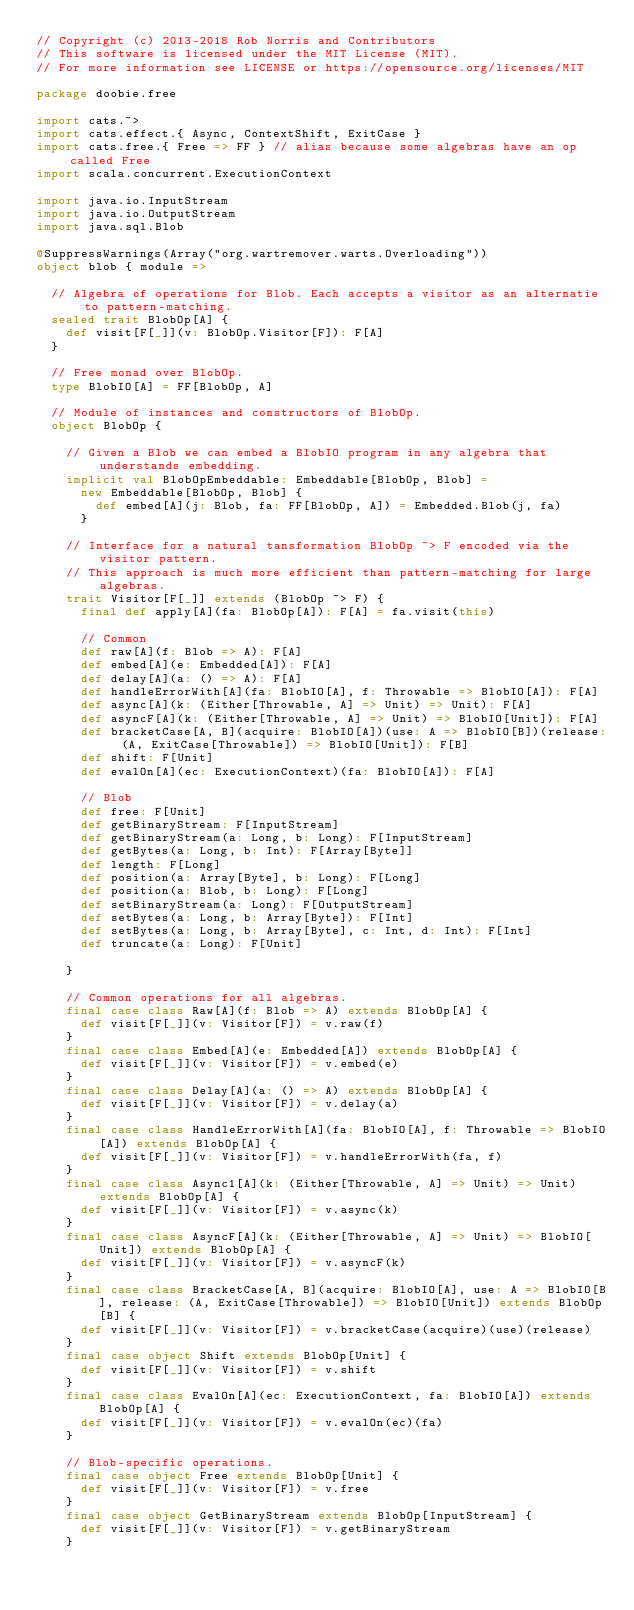<code> <loc_0><loc_0><loc_500><loc_500><_Scala_>// Copyright (c) 2013-2018 Rob Norris and Contributors
// This software is licensed under the MIT License (MIT).
// For more information see LICENSE or https://opensource.org/licenses/MIT

package doobie.free

import cats.~>
import cats.effect.{ Async, ContextShift, ExitCase }
import cats.free.{ Free => FF } // alias because some algebras have an op called Free
import scala.concurrent.ExecutionContext

import java.io.InputStream
import java.io.OutputStream
import java.sql.Blob

@SuppressWarnings(Array("org.wartremover.warts.Overloading"))
object blob { module =>

  // Algebra of operations for Blob. Each accepts a visitor as an alternatie to pattern-matching.
  sealed trait BlobOp[A] {
    def visit[F[_]](v: BlobOp.Visitor[F]): F[A]
  }

  // Free monad over BlobOp.
  type BlobIO[A] = FF[BlobOp, A]

  // Module of instances and constructors of BlobOp.
  object BlobOp {

    // Given a Blob we can embed a BlobIO program in any algebra that understands embedding.
    implicit val BlobOpEmbeddable: Embeddable[BlobOp, Blob] =
      new Embeddable[BlobOp, Blob] {
        def embed[A](j: Blob, fa: FF[BlobOp, A]) = Embedded.Blob(j, fa)
      }

    // Interface for a natural tansformation BlobOp ~> F encoded via the visitor pattern.
    // This approach is much more efficient than pattern-matching for large algebras.
    trait Visitor[F[_]] extends (BlobOp ~> F) {
      final def apply[A](fa: BlobOp[A]): F[A] = fa.visit(this)

      // Common
      def raw[A](f: Blob => A): F[A]
      def embed[A](e: Embedded[A]): F[A]
      def delay[A](a: () => A): F[A]
      def handleErrorWith[A](fa: BlobIO[A], f: Throwable => BlobIO[A]): F[A]
      def async[A](k: (Either[Throwable, A] => Unit) => Unit): F[A]
      def asyncF[A](k: (Either[Throwable, A] => Unit) => BlobIO[Unit]): F[A]
      def bracketCase[A, B](acquire: BlobIO[A])(use: A => BlobIO[B])(release: (A, ExitCase[Throwable]) => BlobIO[Unit]): F[B]
      def shift: F[Unit]
      def evalOn[A](ec: ExecutionContext)(fa: BlobIO[A]): F[A]

      // Blob
      def free: F[Unit]
      def getBinaryStream: F[InputStream]
      def getBinaryStream(a: Long, b: Long): F[InputStream]
      def getBytes(a: Long, b: Int): F[Array[Byte]]
      def length: F[Long]
      def position(a: Array[Byte], b: Long): F[Long]
      def position(a: Blob, b: Long): F[Long]
      def setBinaryStream(a: Long): F[OutputStream]
      def setBytes(a: Long, b: Array[Byte]): F[Int]
      def setBytes(a: Long, b: Array[Byte], c: Int, d: Int): F[Int]
      def truncate(a: Long): F[Unit]

    }

    // Common operations for all algebras.
    final case class Raw[A](f: Blob => A) extends BlobOp[A] {
      def visit[F[_]](v: Visitor[F]) = v.raw(f)
    }
    final case class Embed[A](e: Embedded[A]) extends BlobOp[A] {
      def visit[F[_]](v: Visitor[F]) = v.embed(e)
    }
    final case class Delay[A](a: () => A) extends BlobOp[A] {
      def visit[F[_]](v: Visitor[F]) = v.delay(a)
    }
    final case class HandleErrorWith[A](fa: BlobIO[A], f: Throwable => BlobIO[A]) extends BlobOp[A] {
      def visit[F[_]](v: Visitor[F]) = v.handleErrorWith(fa, f)
    }
    final case class Async1[A](k: (Either[Throwable, A] => Unit) => Unit) extends BlobOp[A] {
      def visit[F[_]](v: Visitor[F]) = v.async(k)
    }
    final case class AsyncF[A](k: (Either[Throwable, A] => Unit) => BlobIO[Unit]) extends BlobOp[A] {
      def visit[F[_]](v: Visitor[F]) = v.asyncF(k)
    }
    final case class BracketCase[A, B](acquire: BlobIO[A], use: A => BlobIO[B], release: (A, ExitCase[Throwable]) => BlobIO[Unit]) extends BlobOp[B] {
      def visit[F[_]](v: Visitor[F]) = v.bracketCase(acquire)(use)(release)
    }
    final case object Shift extends BlobOp[Unit] {
      def visit[F[_]](v: Visitor[F]) = v.shift
    }
    final case class EvalOn[A](ec: ExecutionContext, fa: BlobIO[A]) extends BlobOp[A] {
      def visit[F[_]](v: Visitor[F]) = v.evalOn(ec)(fa)
    }

    // Blob-specific operations.
    final case object Free extends BlobOp[Unit] {
      def visit[F[_]](v: Visitor[F]) = v.free
    }
    final case object GetBinaryStream extends BlobOp[InputStream] {
      def visit[F[_]](v: Visitor[F]) = v.getBinaryStream
    }</code> 